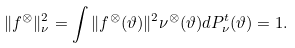<formula> <loc_0><loc_0><loc_500><loc_500>\| f ^ { \otimes } \| ^ { 2 } _ { \nu } = \int \| f ^ { \otimes } ( \vartheta ) \| ^ { 2 } \nu ^ { \otimes } ( \vartheta ) d P ^ { t } _ { \nu } ( \vartheta ) = 1 .</formula> 